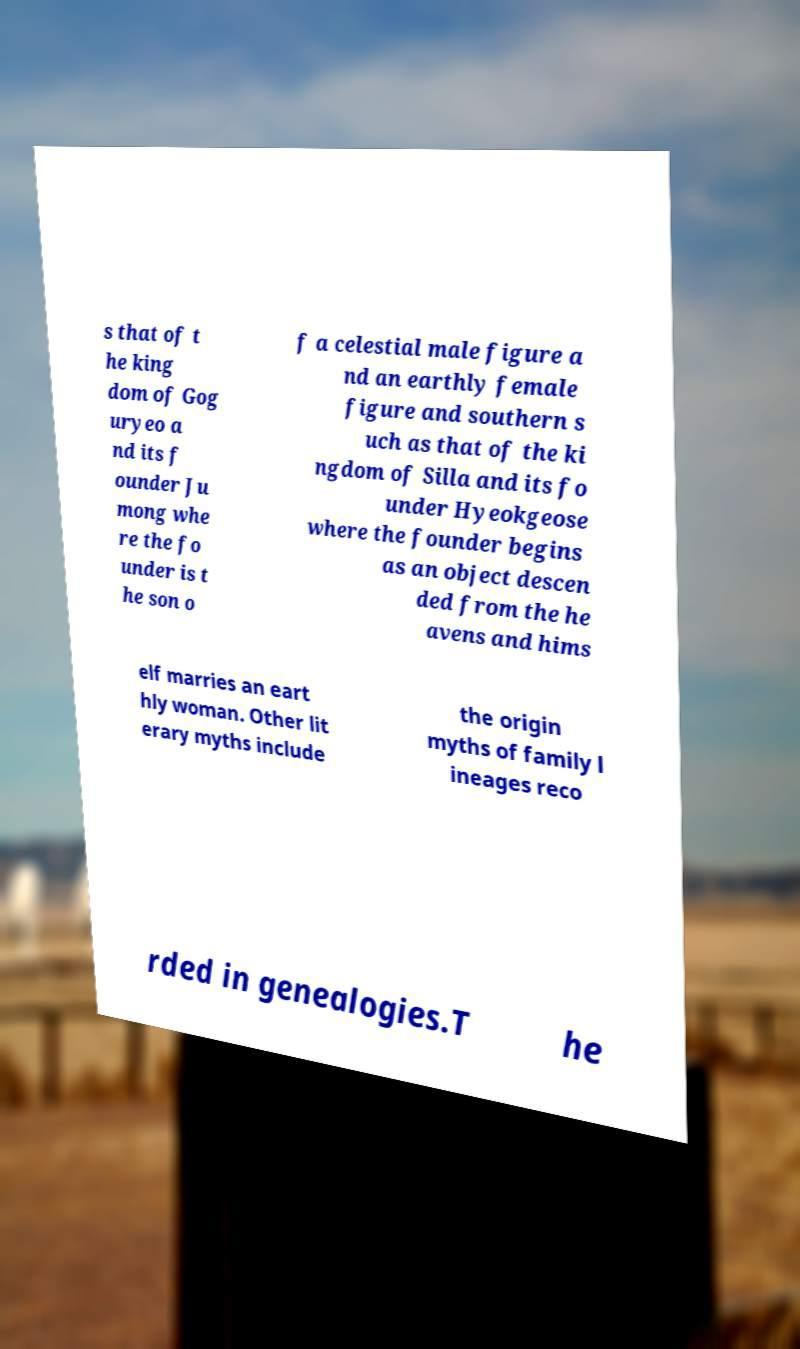Please read and relay the text visible in this image. What does it say? s that of t he king dom of Gog uryeo a nd its f ounder Ju mong whe re the fo under is t he son o f a celestial male figure a nd an earthly female figure and southern s uch as that of the ki ngdom of Silla and its fo under Hyeokgeose where the founder begins as an object descen ded from the he avens and hims elf marries an eart hly woman. Other lit erary myths include the origin myths of family l ineages reco rded in genealogies.T he 